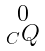Convert formula to latex. <formula><loc_0><loc_0><loc_500><loc_500>\begin{smallmatrix} 0 \\ _ { C } Q \end{smallmatrix}</formula> 